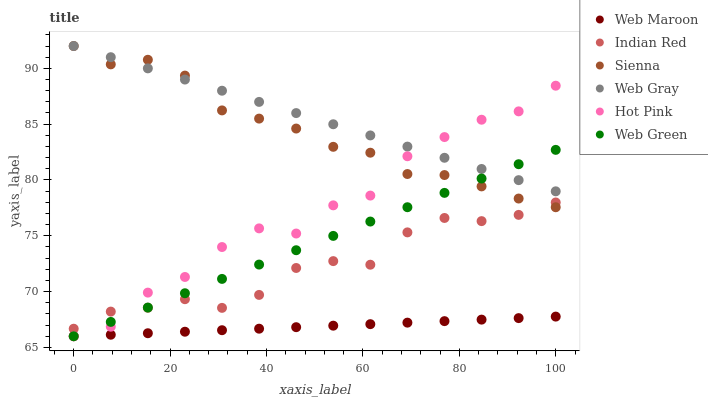Does Web Maroon have the minimum area under the curve?
Answer yes or no. Yes. Does Web Gray have the maximum area under the curve?
Answer yes or no. Yes. Does Hot Pink have the minimum area under the curve?
Answer yes or no. No. Does Hot Pink have the maximum area under the curve?
Answer yes or no. No. Is Web Maroon the smoothest?
Answer yes or no. Yes. Is Hot Pink the roughest?
Answer yes or no. Yes. Is Hot Pink the smoothest?
Answer yes or no. No. Is Web Maroon the roughest?
Answer yes or no. No. Does Hot Pink have the lowest value?
Answer yes or no. Yes. Does Sienna have the lowest value?
Answer yes or no. No. Does Sienna have the highest value?
Answer yes or no. Yes. Does Hot Pink have the highest value?
Answer yes or no. No. Is Web Maroon less than Sienna?
Answer yes or no. Yes. Is Indian Red greater than Web Maroon?
Answer yes or no. Yes. Does Web Gray intersect Web Green?
Answer yes or no. Yes. Is Web Gray less than Web Green?
Answer yes or no. No. Is Web Gray greater than Web Green?
Answer yes or no. No. Does Web Maroon intersect Sienna?
Answer yes or no. No. 